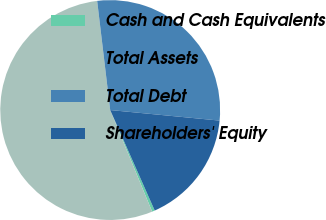Convert chart. <chart><loc_0><loc_0><loc_500><loc_500><pie_chart><fcel>Cash and Cash Equivalents<fcel>Total Assets<fcel>Total Debt<fcel>Shareholders' Equity<nl><fcel>0.41%<fcel>54.34%<fcel>28.42%<fcel>16.83%<nl></chart> 